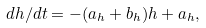Convert formula to latex. <formula><loc_0><loc_0><loc_500><loc_500>d h / d t = - ( a _ { h } + b _ { h } ) h + a _ { h } ,</formula> 